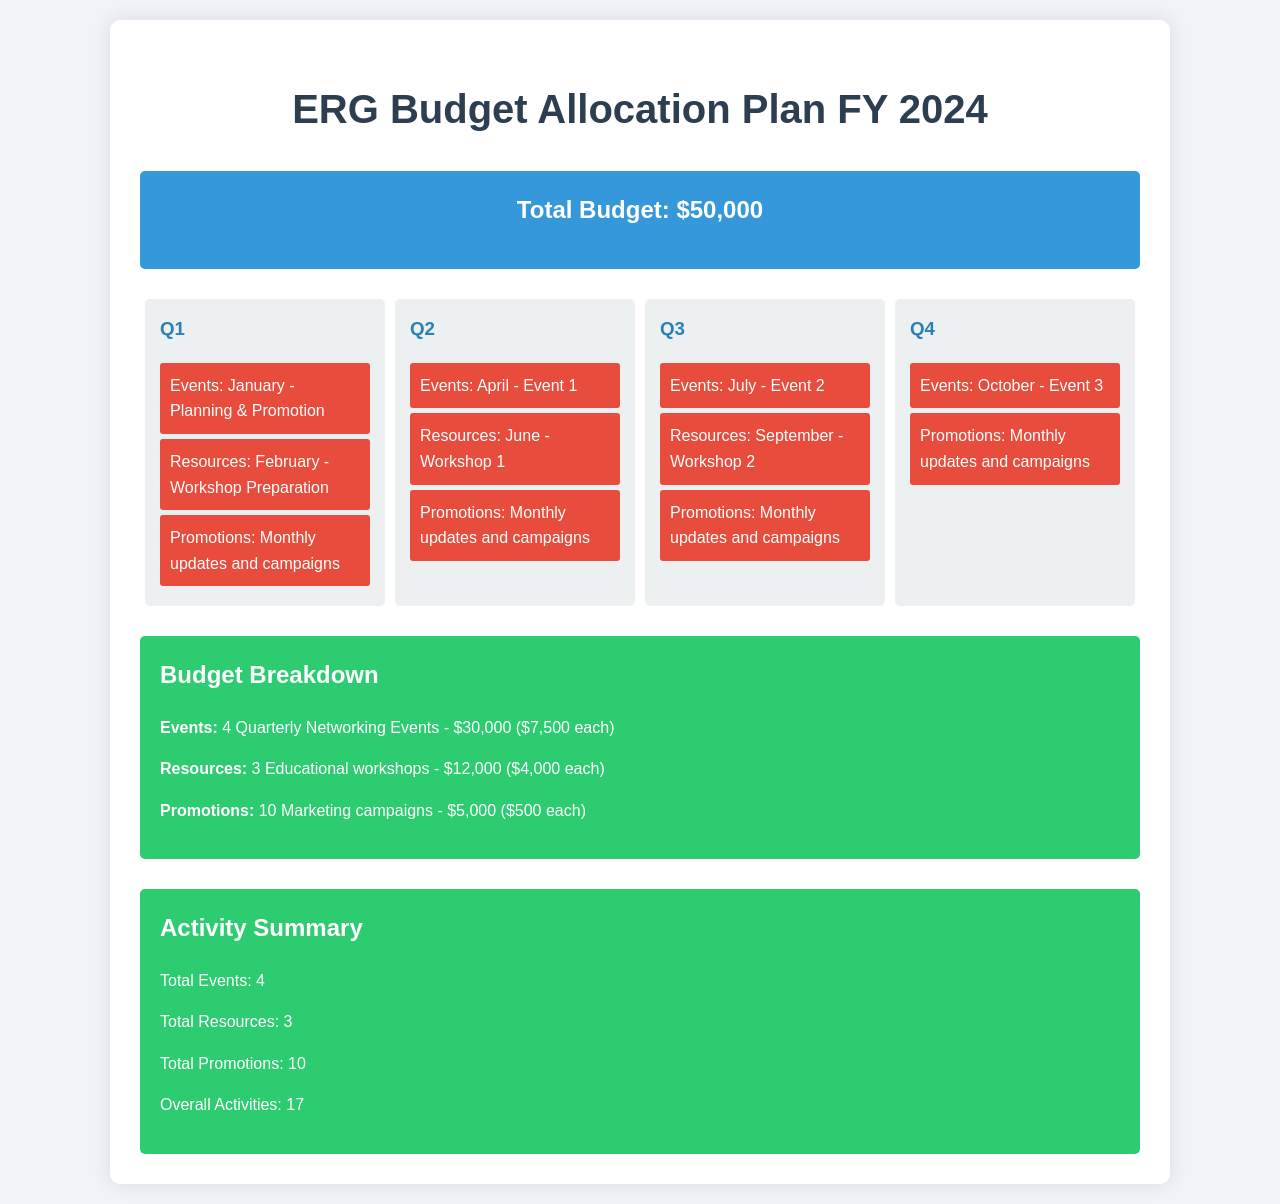What is the total budget for FY 2024? The total budget is stated in the document under the budget summary section.
Answer: $50,000 How many events are planned for the year? The total number of events is summarized in the activity summary section of the document.
Answer: 4 When is the first event scheduled? The first event is detailed in the Q1 section of the timeline.
Answer: January What is the cost for each educational workshop? The cost per workshop is mentioned in the budget breakdown section.
Answer: $4,000 How many marketing campaigns are included in the budget? The number of marketing campaigns is provided in the summary of budget breakdown.
Answer: 10 What quarter is the second event scheduled for? The quarter for the second event is specified in the Q3 section of the timeline.
Answer: Q3 What is the total cost allocated for promotions? The total cost for promotions is mentioned in the budget breakdown section.
Answer: $5,000 Which month is the workshop preparation scheduled? The month for workshop preparation is found in the Q1 section of the timeline.
Answer: February What is the total number of overall activities planned? The total number of overall activities is summarized in the activity summary section.
Answer: 17 